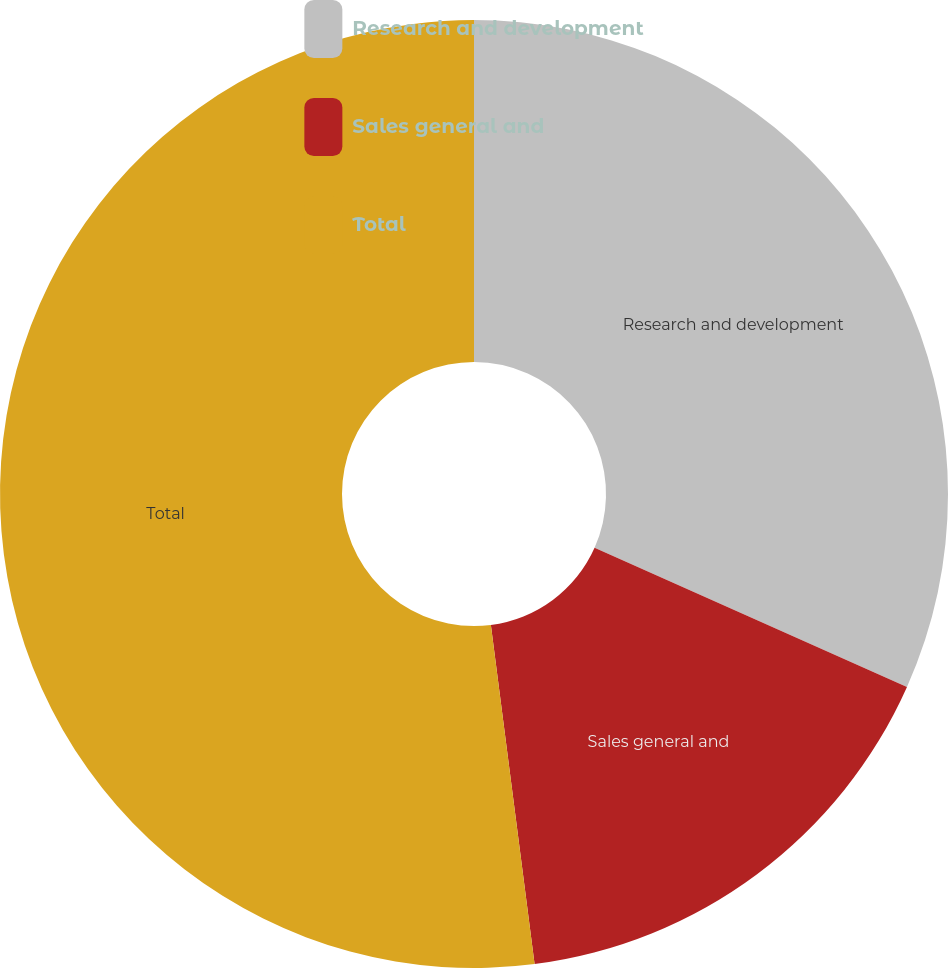<chart> <loc_0><loc_0><loc_500><loc_500><pie_chart><fcel>Research and development<fcel>Sales general and<fcel>Total<nl><fcel>31.67%<fcel>16.29%<fcel>52.04%<nl></chart> 